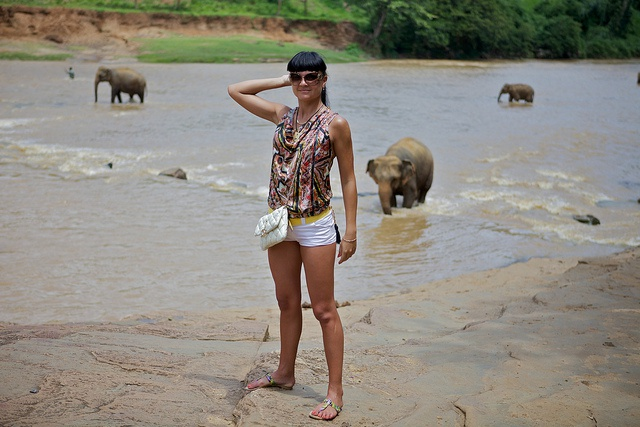Describe the objects in this image and their specific colors. I can see people in darkgreen, maroon, darkgray, and brown tones, elephant in darkgreen, black, tan, gray, and maroon tones, handbag in darkgreen, darkgray, lightgray, and gray tones, elephant in darkgreen, black, and gray tones, and elephant in darkgreen, gray, and black tones in this image. 